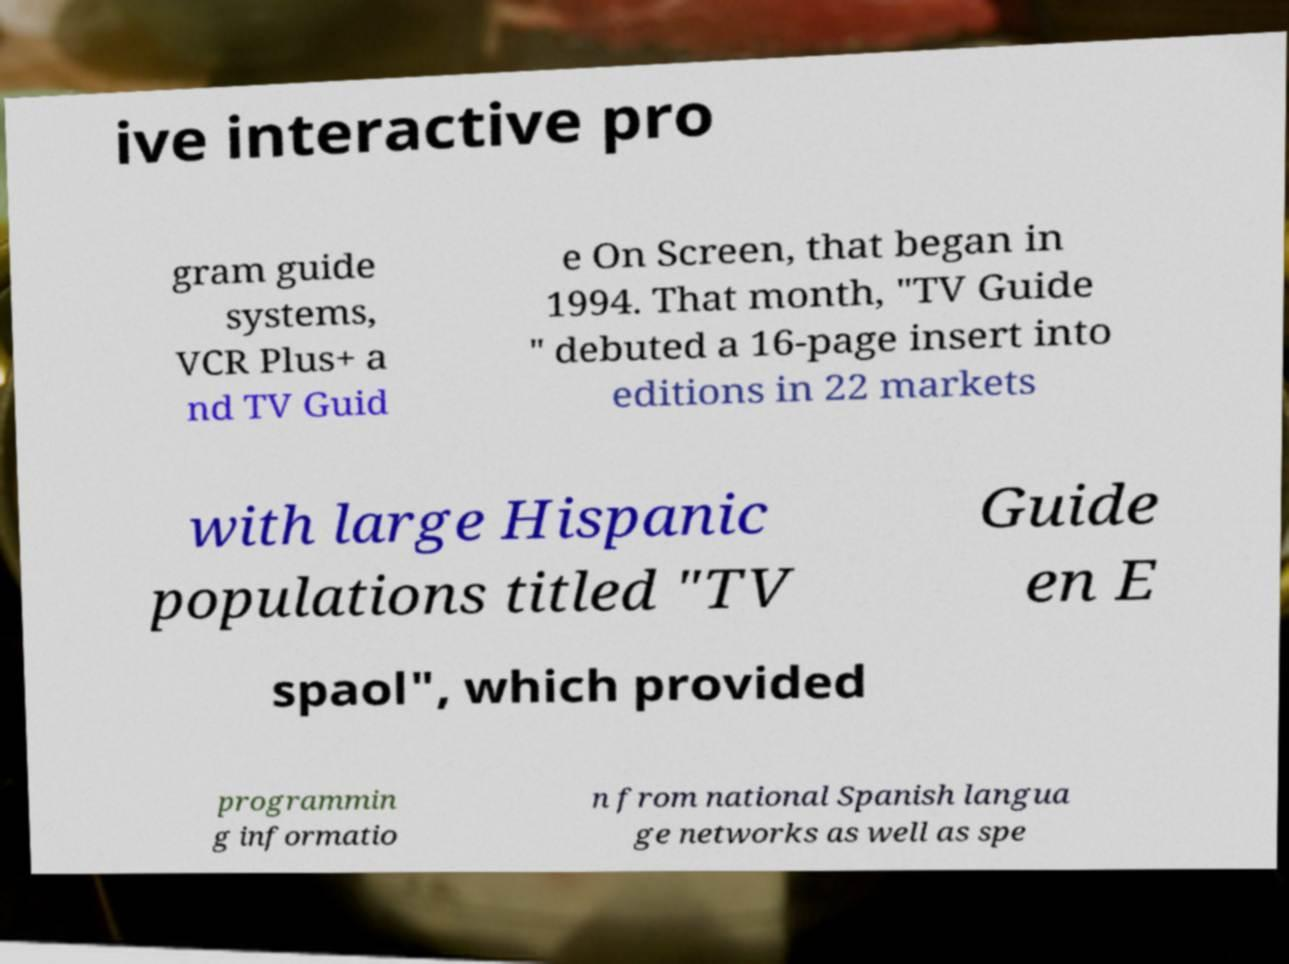There's text embedded in this image that I need extracted. Can you transcribe it verbatim? ive interactive pro gram guide systems, VCR Plus+ a nd TV Guid e On Screen, that began in 1994. That month, "TV Guide " debuted a 16-page insert into editions in 22 markets with large Hispanic populations titled "TV Guide en E spaol", which provided programmin g informatio n from national Spanish langua ge networks as well as spe 